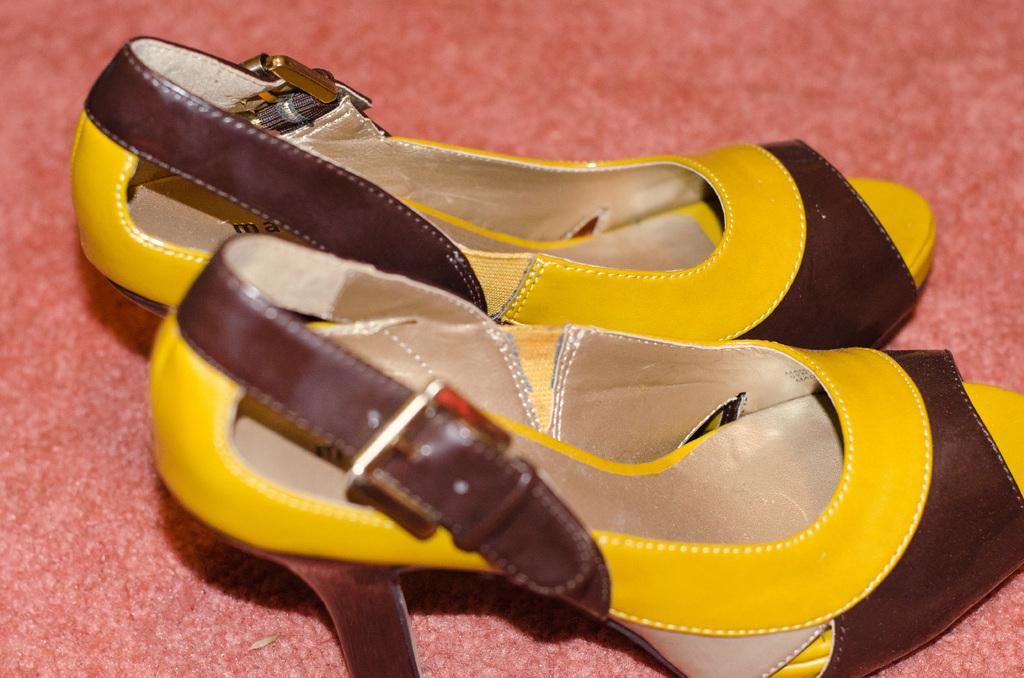What is present in the image? There is a footwear in the image. Where is the footwear placed? The footwear is placed on a mat. How are the footwear and mat positioned in the image? The footwear and mat are in the center of the image. How many rings are visible on the footwear in the image? There are no rings visible on the footwear in the image. What type of pets can be seen playing with the footwear in the image? There are no pets present in the image, and the footwear is not being played with. 